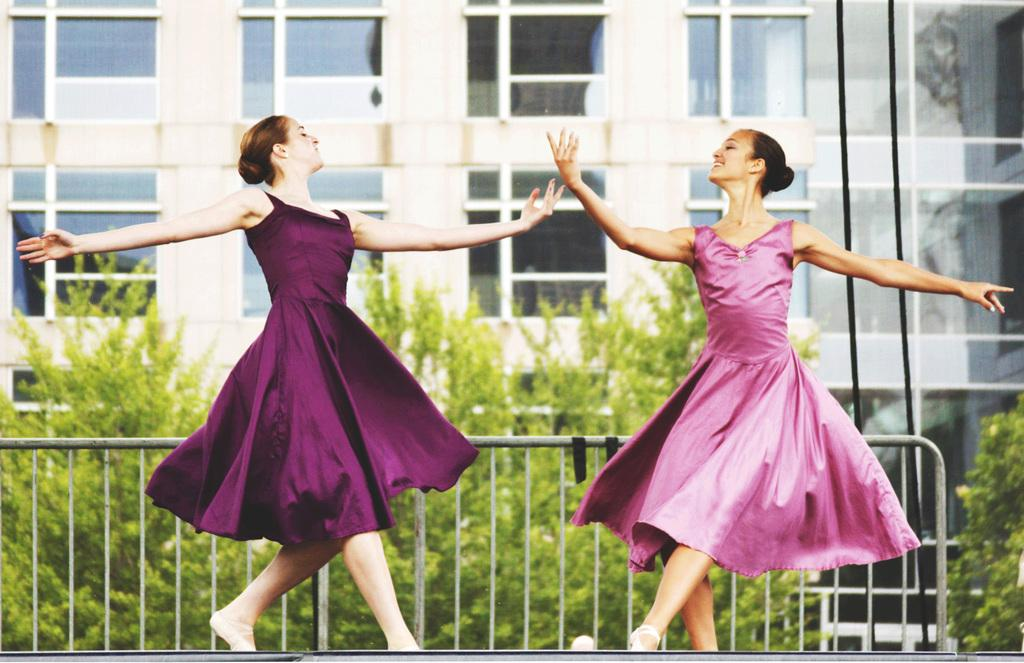What are the two women in the image doing? The two women are dancing in the image. What can be seen in the background of the image? There is a fence, trees, a building, and glass doors in the background of the image. Are there any additional features on the right side of the image? Yes, there are two wires on the right side of the image. What type of art is displayed on the badge worn by one of the women in the image? There is no badge visible in the image, and therefore no art can be observed on it. 